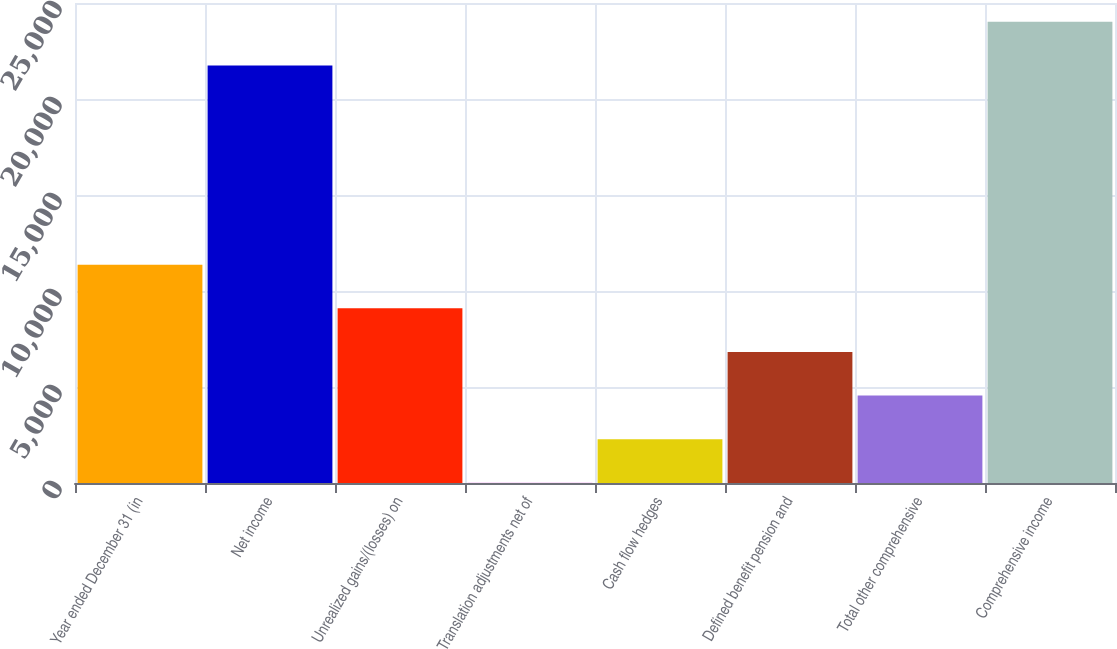<chart> <loc_0><loc_0><loc_500><loc_500><bar_chart><fcel>Year ended December 31 (in<fcel>Net income<fcel>Unrealized gains/(losses) on<fcel>Translation adjustments net of<fcel>Cash flow hedges<fcel>Defined benefit pension and<fcel>Total other comprehensive<fcel>Comprehensive income<nl><fcel>11373<fcel>21745<fcel>9100.6<fcel>11<fcel>2283.4<fcel>6828.2<fcel>4555.8<fcel>24017.4<nl></chart> 